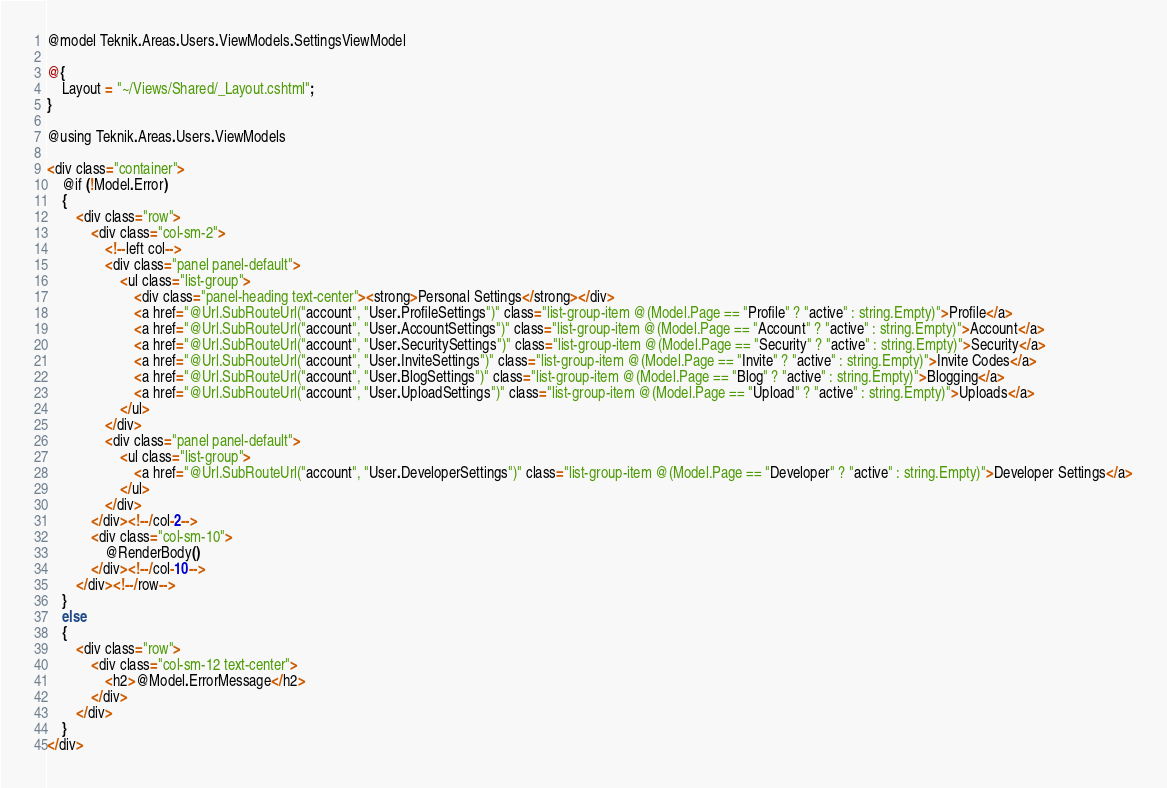Convert code to text. <code><loc_0><loc_0><loc_500><loc_500><_C#_>@model Teknik.Areas.Users.ViewModels.SettingsViewModel

@{
    Layout = "~/Views/Shared/_Layout.cshtml";
}

@using Teknik.Areas.Users.ViewModels

<div class="container">
    @if (!Model.Error)
    {
        <div class="row">
            <div class="col-sm-2">
                <!--left col-->
                <div class="panel panel-default">
                    <ul class="list-group">
                        <div class="panel-heading text-center"><strong>Personal Settings</strong></div>
                        <a href="@Url.SubRouteUrl("account", "User.ProfileSettings")" class="list-group-item @(Model.Page == "Profile" ? "active" : string.Empty)">Profile</a>
                        <a href="@Url.SubRouteUrl("account", "User.AccountSettings")" class="list-group-item @(Model.Page == "Account" ? "active" : string.Empty)">Account</a>
                        <a href="@Url.SubRouteUrl("account", "User.SecuritySettings")" class="list-group-item @(Model.Page == "Security" ? "active" : string.Empty)">Security</a>
                        <a href="@Url.SubRouteUrl("account", "User.InviteSettings")" class="list-group-item @(Model.Page == "Invite" ? "active" : string.Empty)">Invite Codes</a>
                        <a href="@Url.SubRouteUrl("account", "User.BlogSettings")" class="list-group-item @(Model.Page == "Blog" ? "active" : string.Empty)">Blogging</a>
                        <a href="@Url.SubRouteUrl("account", "User.UploadSettings")" class="list-group-item @(Model.Page == "Upload" ? "active" : string.Empty)">Uploads</a>
                    </ul>
                </div>
                <div class="panel panel-default">
                    <ul class="list-group">
                        <a href="@Url.SubRouteUrl("account", "User.DeveloperSettings")" class="list-group-item @(Model.Page == "Developer" ? "active" : string.Empty)">Developer Settings</a>
                    </ul>
                </div>
            </div><!--/col-2-->
            <div class="col-sm-10">
                @RenderBody()
            </div><!--/col-10-->
        </div><!--/row-->
    }
    else
    {
        <div class="row">
            <div class="col-sm-12 text-center">
                <h2>@Model.ErrorMessage</h2>
            </div>
        </div>
    }
</div></code> 